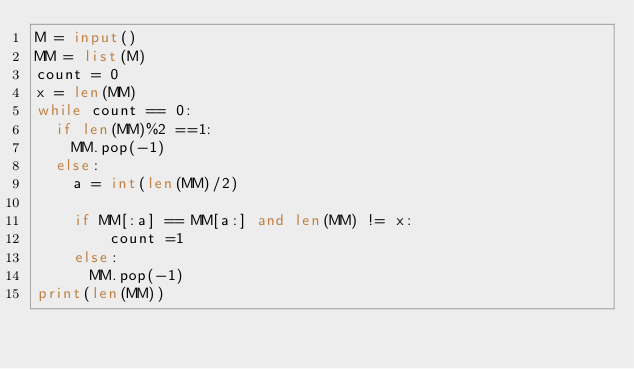<code> <loc_0><loc_0><loc_500><loc_500><_Python_>M = input()
MM = list(M)
count = 0
x = len(MM)
while count == 0:
  if len(MM)%2 ==1:
    MM.pop(-1)
  else:
    a = int(len(MM)/2)
    
    if MM[:a] == MM[a:] and len(MM) != x:
        count =1
    else:
      MM.pop(-1)
print(len(MM))</code> 